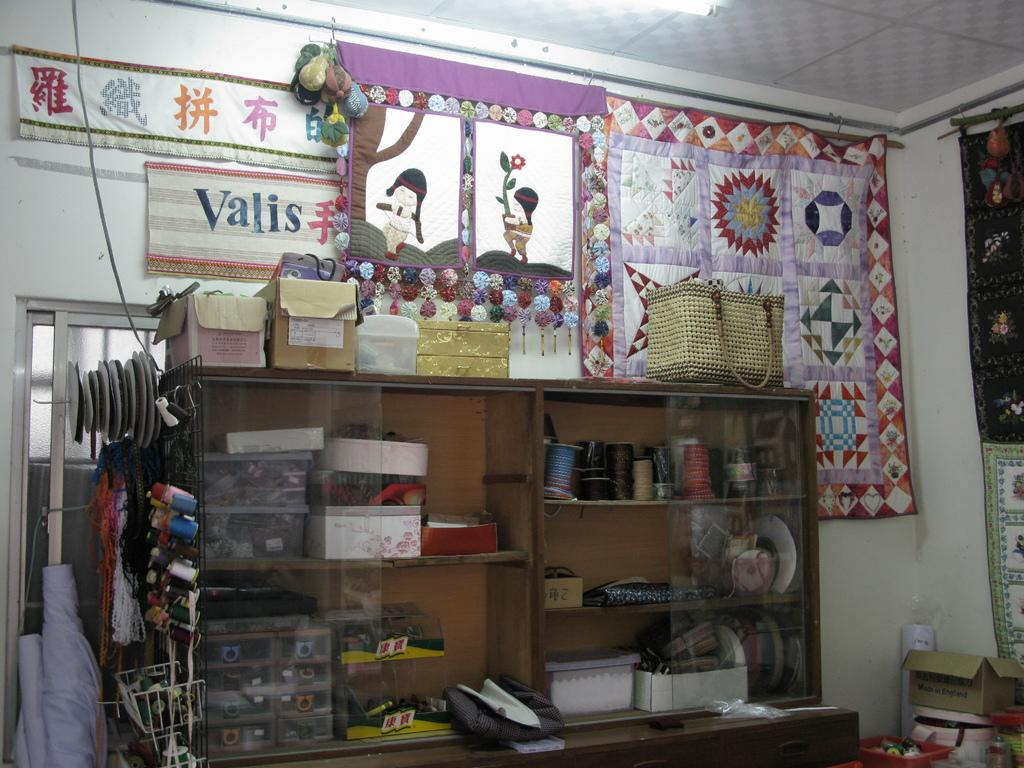<image>
Share a concise interpretation of the image provided. a shop has a poster with the word Valis on it 